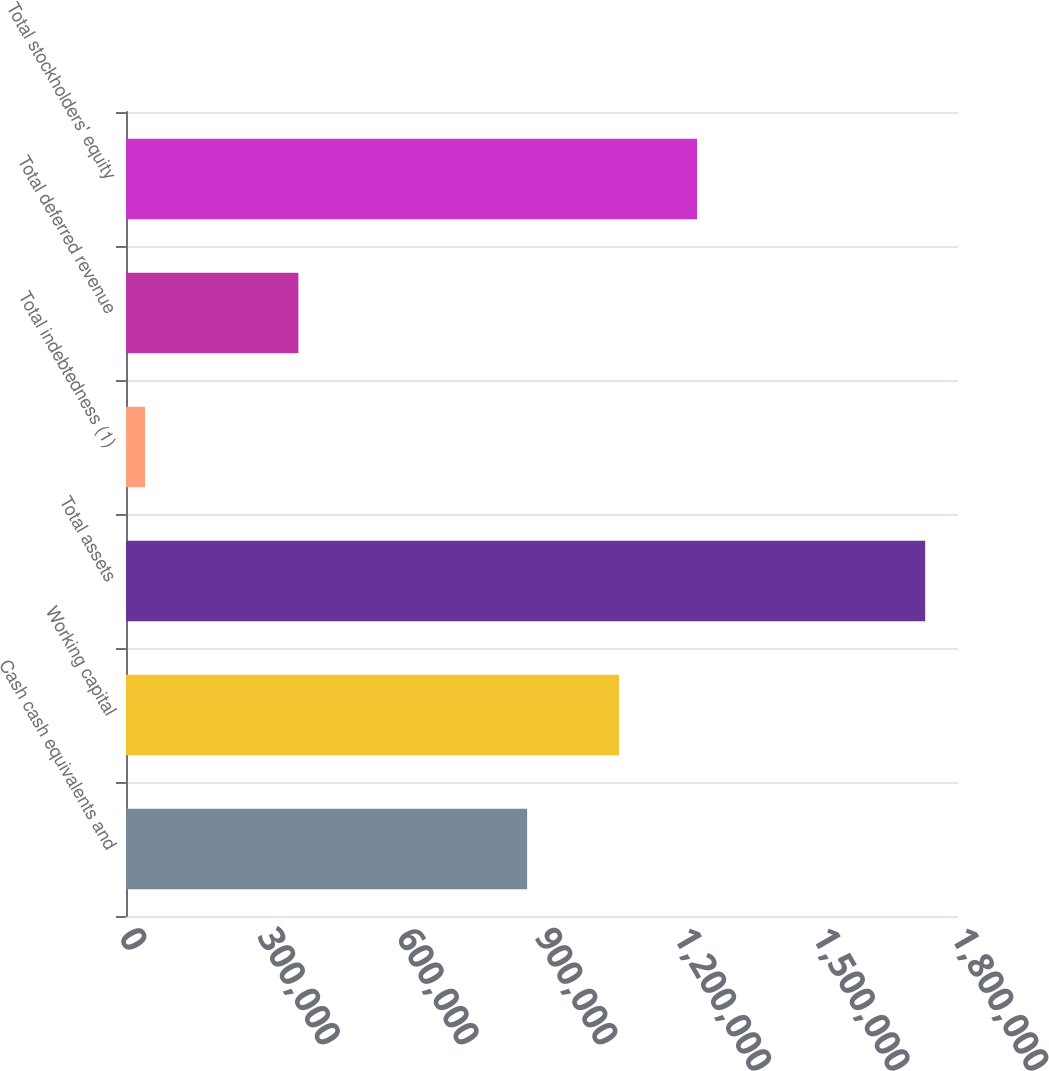<chart> <loc_0><loc_0><loc_500><loc_500><bar_chart><fcel>Cash cash equivalents and<fcel>Working capital<fcel>Total assets<fcel>Total indebtedness (1)<fcel>Total deferred revenue<fcel>Total stockholders' equity<nl><fcel>867833<fcel>1.06657e+06<fcel>1.72901e+06<fcel>41210<fcel>372935<fcel>1.23535e+06<nl></chart> 